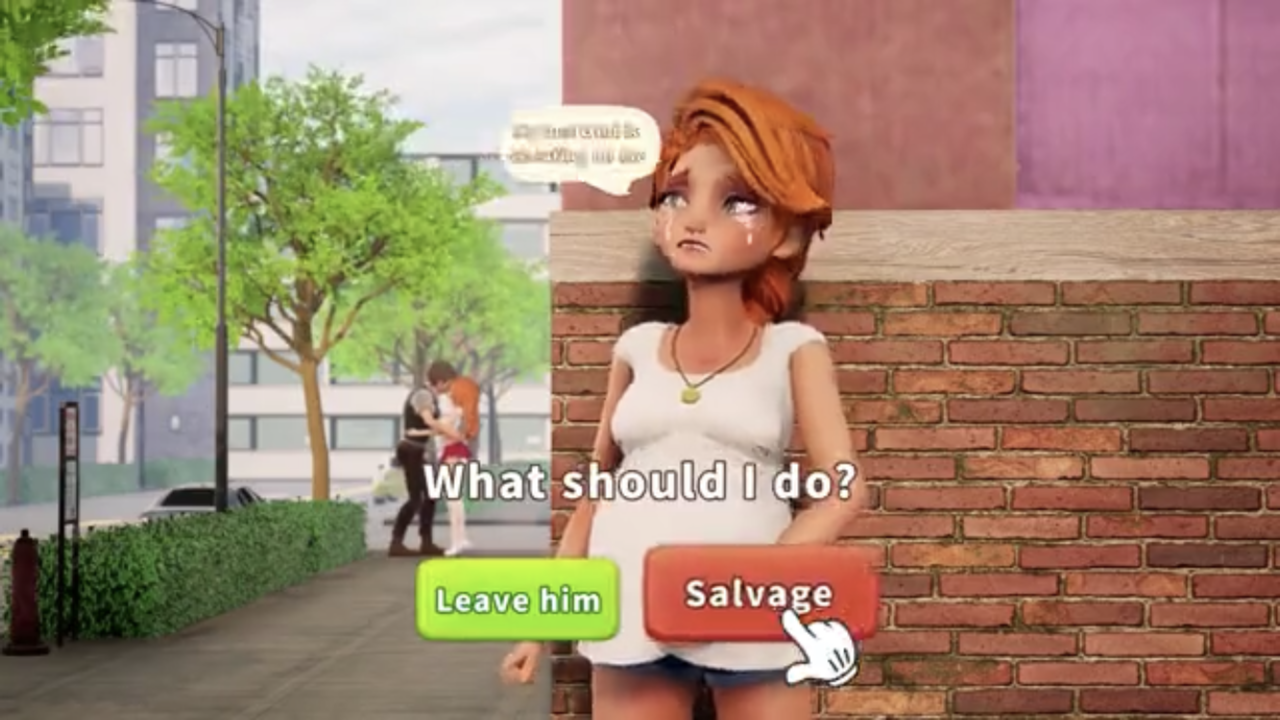Describe the image in detail. Return a comma separated list of succinct tags. The image depicts a character from an interactive game or story. The character appears to be a young woman with short, reddish-brown hair, looking concerned or distressed. She stands in front of a brick wall, with a street scene visible in the background. Two options are presented to the player: "Leave him" and "Salvage". I will avoid identifying any individuals in the image.

Tags: interactive game, young woman, distressed, brick wall, street scene, decision, leave, salvage. 